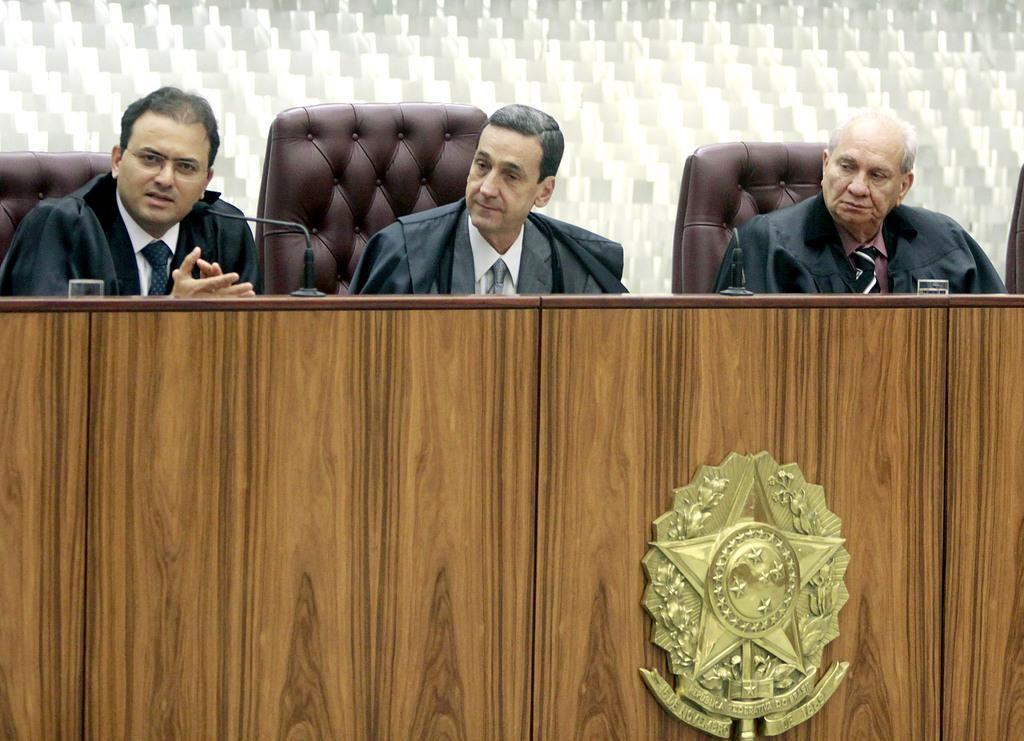Could you give a brief overview of what you see in this image? In this image I can see three men are sitting on chairs. I can see all of them are wearing black coats and formal dress. In the front of them I can see a brown colour table and on it I can see few mics and two glasses. On the bottom right side of the image I can see a badge on the table. 